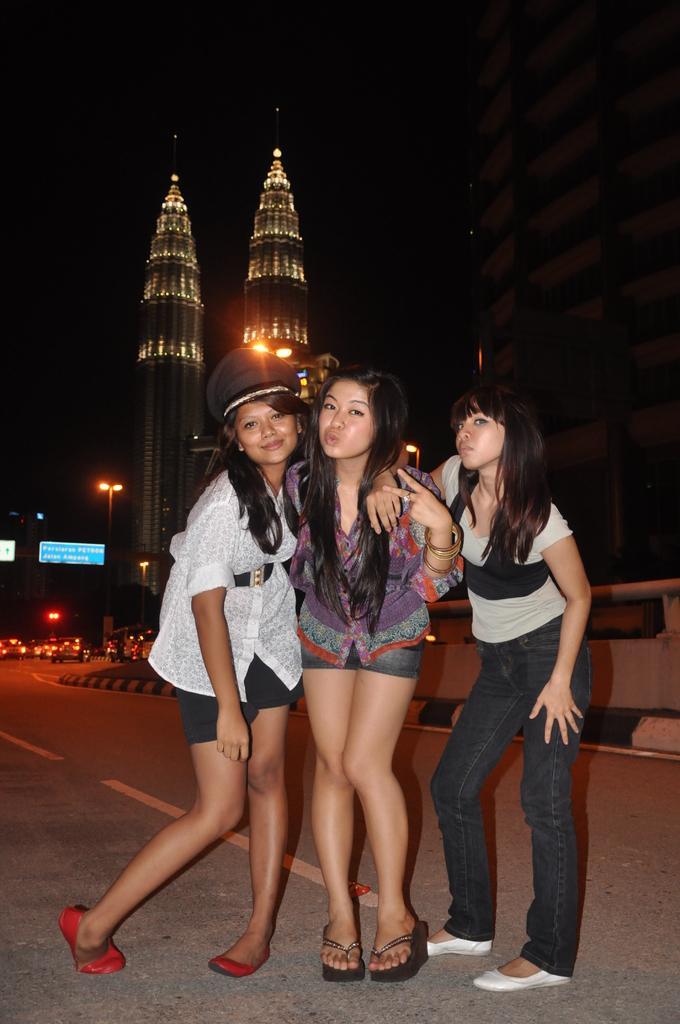How many people are in the image? There are three persons standing in the image. What are the people in the image doing? The persons are posing for a picture. What can be seen in the background of the image? The background of the image is dark. What other elements are present in the image besides the people? There are buildings, lights, vehicles, and name boards in the image. What type of coil can be seen wrapped around the middle person's leg in the image? There is: There is no coil or any object wrapped around any person's leg in the image. 